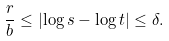Convert formula to latex. <formula><loc_0><loc_0><loc_500><loc_500>\frac { r } { b } \leq \left | \log s - \log t \right | \leq \delta .</formula> 